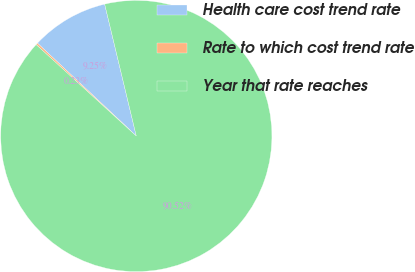Convert chart. <chart><loc_0><loc_0><loc_500><loc_500><pie_chart><fcel>Health care cost trend rate<fcel>Rate to which cost trend rate<fcel>Year that rate reaches<nl><fcel>9.25%<fcel>0.23%<fcel>90.52%<nl></chart> 